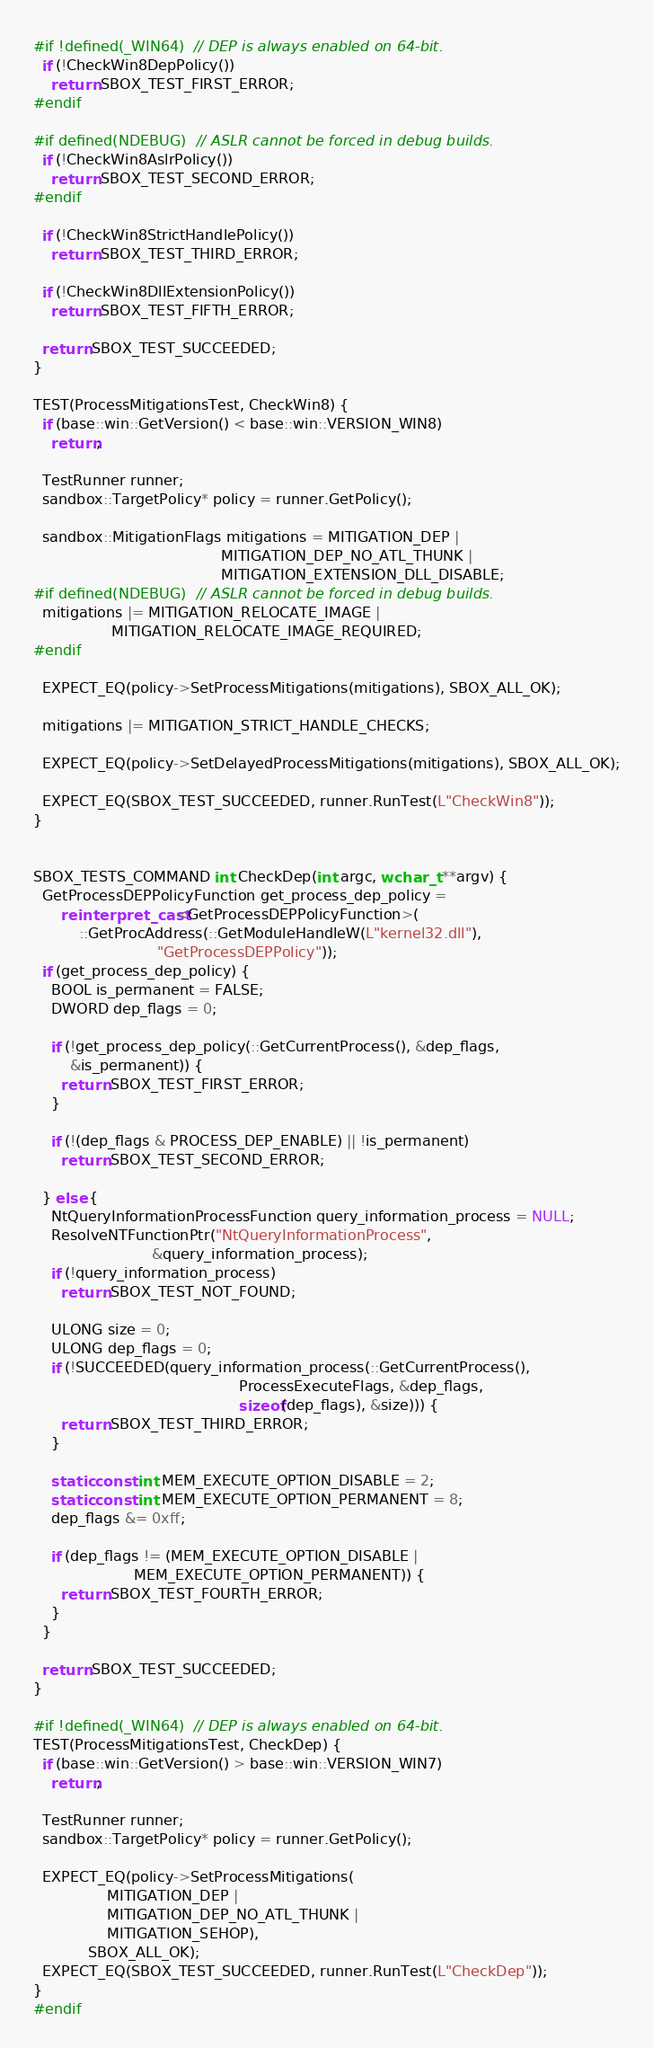<code> <loc_0><loc_0><loc_500><loc_500><_C++_>#if !defined(_WIN64)  // DEP is always enabled on 64-bit.
  if (!CheckWin8DepPolicy())
    return SBOX_TEST_FIRST_ERROR;
#endif

#if defined(NDEBUG)  // ASLR cannot be forced in debug builds.
  if (!CheckWin8AslrPolicy())
    return SBOX_TEST_SECOND_ERROR;
#endif

  if (!CheckWin8StrictHandlePolicy())
    return SBOX_TEST_THIRD_ERROR;

  if (!CheckWin8DllExtensionPolicy())
    return SBOX_TEST_FIFTH_ERROR;

  return SBOX_TEST_SUCCEEDED;
}

TEST(ProcessMitigationsTest, CheckWin8) {
  if (base::win::GetVersion() < base::win::VERSION_WIN8)
    return;

  TestRunner runner;
  sandbox::TargetPolicy* policy = runner.GetPolicy();

  sandbox::MitigationFlags mitigations = MITIGATION_DEP |
                                         MITIGATION_DEP_NO_ATL_THUNK |
                                         MITIGATION_EXTENSION_DLL_DISABLE;
#if defined(NDEBUG)  // ASLR cannot be forced in debug builds.
  mitigations |= MITIGATION_RELOCATE_IMAGE |
                 MITIGATION_RELOCATE_IMAGE_REQUIRED;
#endif

  EXPECT_EQ(policy->SetProcessMitigations(mitigations), SBOX_ALL_OK);

  mitigations |= MITIGATION_STRICT_HANDLE_CHECKS;

  EXPECT_EQ(policy->SetDelayedProcessMitigations(mitigations), SBOX_ALL_OK);

  EXPECT_EQ(SBOX_TEST_SUCCEEDED, runner.RunTest(L"CheckWin8"));
}


SBOX_TESTS_COMMAND int CheckDep(int argc, wchar_t **argv) {
  GetProcessDEPPolicyFunction get_process_dep_policy =
      reinterpret_cast<GetProcessDEPPolicyFunction>(
          ::GetProcAddress(::GetModuleHandleW(L"kernel32.dll"),
                           "GetProcessDEPPolicy"));
  if (get_process_dep_policy) {
    BOOL is_permanent = FALSE;
    DWORD dep_flags = 0;

    if (!get_process_dep_policy(::GetCurrentProcess(), &dep_flags,
        &is_permanent)) {
      return SBOX_TEST_FIRST_ERROR;
    }

    if (!(dep_flags & PROCESS_DEP_ENABLE) || !is_permanent)
      return SBOX_TEST_SECOND_ERROR;

  } else {
    NtQueryInformationProcessFunction query_information_process = NULL;
    ResolveNTFunctionPtr("NtQueryInformationProcess",
                          &query_information_process);
    if (!query_information_process)
      return SBOX_TEST_NOT_FOUND;

    ULONG size = 0;
    ULONG dep_flags = 0;
    if (!SUCCEEDED(query_information_process(::GetCurrentProcess(),
                                             ProcessExecuteFlags, &dep_flags,
                                             sizeof(dep_flags), &size))) {
      return SBOX_TEST_THIRD_ERROR;
    }

    static const int MEM_EXECUTE_OPTION_DISABLE = 2;
    static const int MEM_EXECUTE_OPTION_PERMANENT = 8;
    dep_flags &= 0xff;

    if (dep_flags != (MEM_EXECUTE_OPTION_DISABLE |
                      MEM_EXECUTE_OPTION_PERMANENT)) {
      return SBOX_TEST_FOURTH_ERROR;
    }
  }

  return SBOX_TEST_SUCCEEDED;
}

#if !defined(_WIN64)  // DEP is always enabled on 64-bit.
TEST(ProcessMitigationsTest, CheckDep) {
  if (base::win::GetVersion() > base::win::VERSION_WIN7)
    return;

  TestRunner runner;
  sandbox::TargetPolicy* policy = runner.GetPolicy();

  EXPECT_EQ(policy->SetProcessMitigations(
                MITIGATION_DEP |
                MITIGATION_DEP_NO_ATL_THUNK |
                MITIGATION_SEHOP),
            SBOX_ALL_OK);
  EXPECT_EQ(SBOX_TEST_SUCCEEDED, runner.RunTest(L"CheckDep"));
}
#endif
</code> 